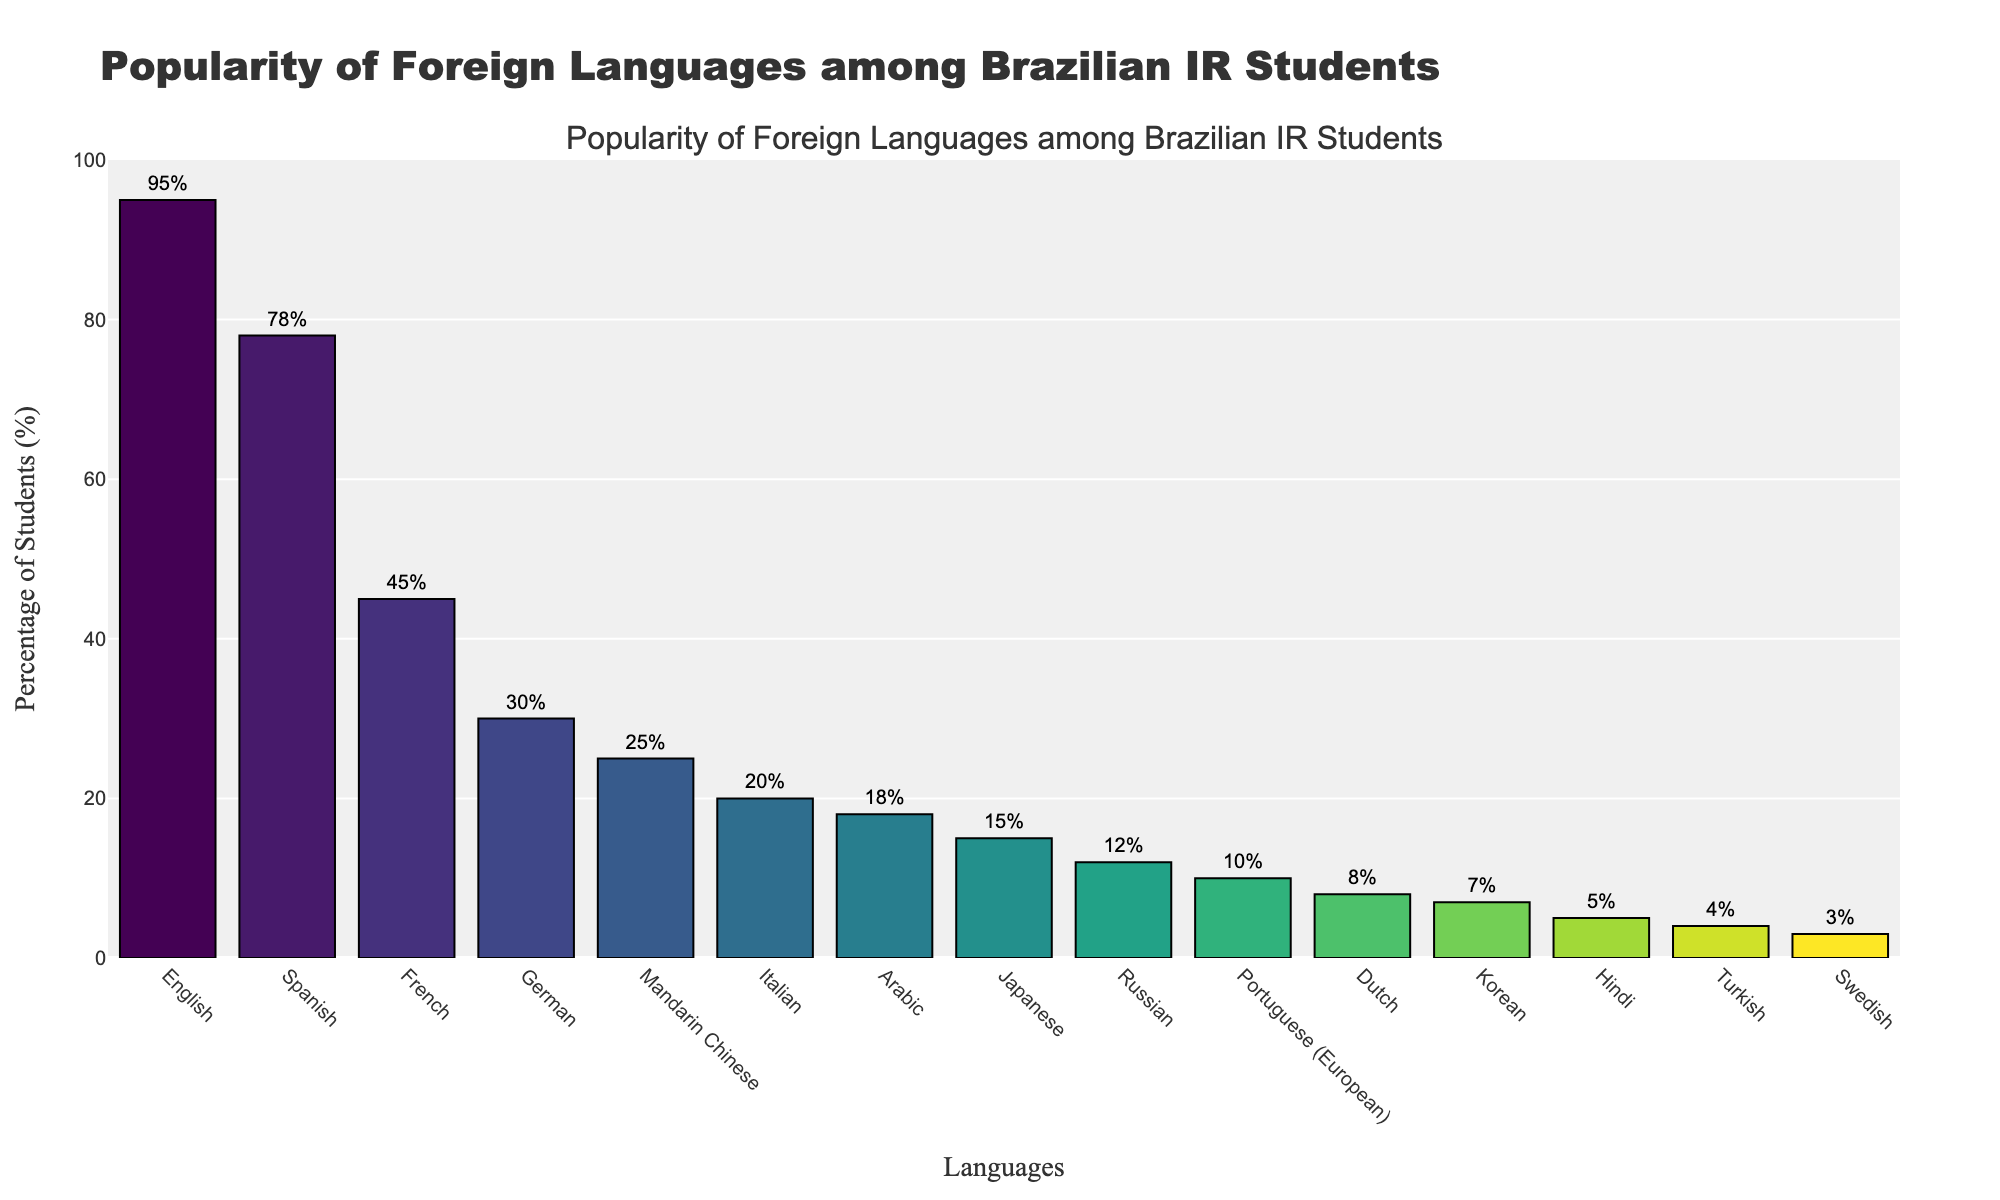Which language is the most popular among Brazilian international relations students? The tallest bar represents the most popular language, which is English with 95%.
Answer: English How many more students prefer Spanish over French? The difference between the percentages of students who prefer Spanish and French is 78% - 45% = 33%.
Answer: 33% Out of the top three languages, what is the average percentage of students? The top three languages are English (95%), Spanish (78%), and French (45%). The average is (95 + 78 + 45) / 3 = 72.67%.
Answer: 72.67% Rank Mandarin Chinese, Arabic, and Japanese in terms of popularity from highest to lowest. Referring to the heights of the bars, Mandarin Chinese is 25%, Arabic is 18%, and Japanese is 15%.
Answer: Mandarin Chinese, Arabic, Japanese Is the percentage of students who prefer Italian greater than those who prefer Japanese? Comparing the heights of the bars, the percentage for Italian (20%) is greater than Japanese (15%).
Answer: Yes Which language has the least popularity among Brazilian international relations students? The shortest bar represents the least popular language, which is Swedish with 3%.
Answer: Swedish How many languages have a percentage higher than 20%? Counting the bars with percentages higher than 20%, they are English, Spanish, French, German, and Mandarin Chinese. That's a total of 5 languages.
Answer: 5 Are there more students interested in German or in Mandarin Chinese? By how much? By comparing the bars, we see that German has 30% and Mandarin Chinese has 25%, so there are 30% - 25% = 5% more students interested in German.
Answer: German by 5% What is the combined percentage of students who prefer German, Italian, and Korean? Summing the percentages for German (30%), Italian (20%), and Korean (7%), the total is 30 + 20 + 7 = 57%.
Answer: 57% 